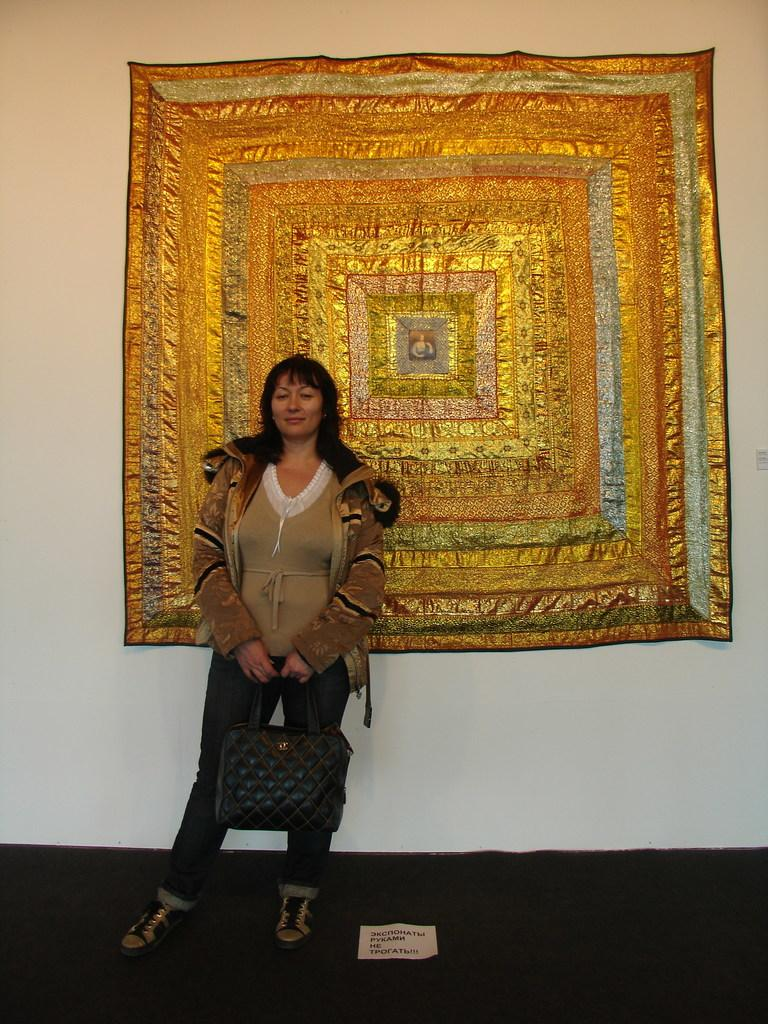Who is present in the image? There is a woman in the image. What is the woman doing in the image? The woman is standing in the image. What is the woman wearing in the image? The woman is wearing a coat in the image. What is the woman holding in the image? The woman is holding a bag in the image. What can be seen on the wall in the background of the image? There is a cloth on the wall in the background of the image. What type of mitten can be seen on the woman's hand in the image? There is no mitten visible on the woman's hand in the image. What time of day is it in the image, considering the night topic? The provided facts do not mention the time of day or any reference to night, so it cannot be determined from the image. 